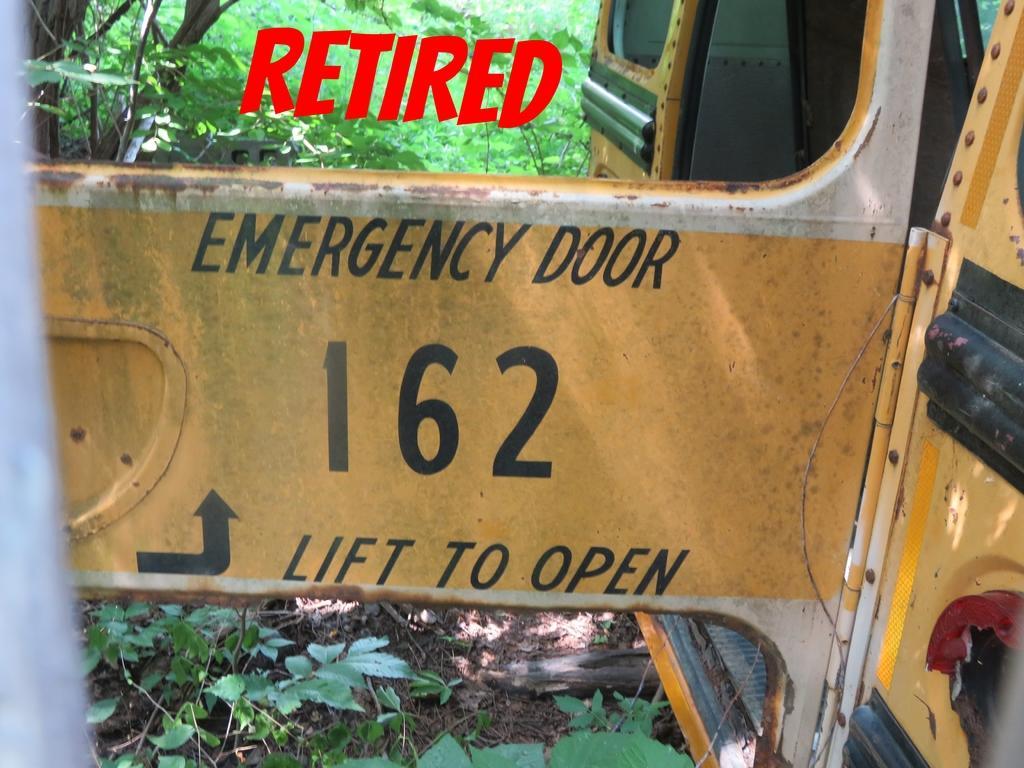Describe this image in one or two sentences. In the image we can see a vehicle. Behind the vehicle we can see some trees. 